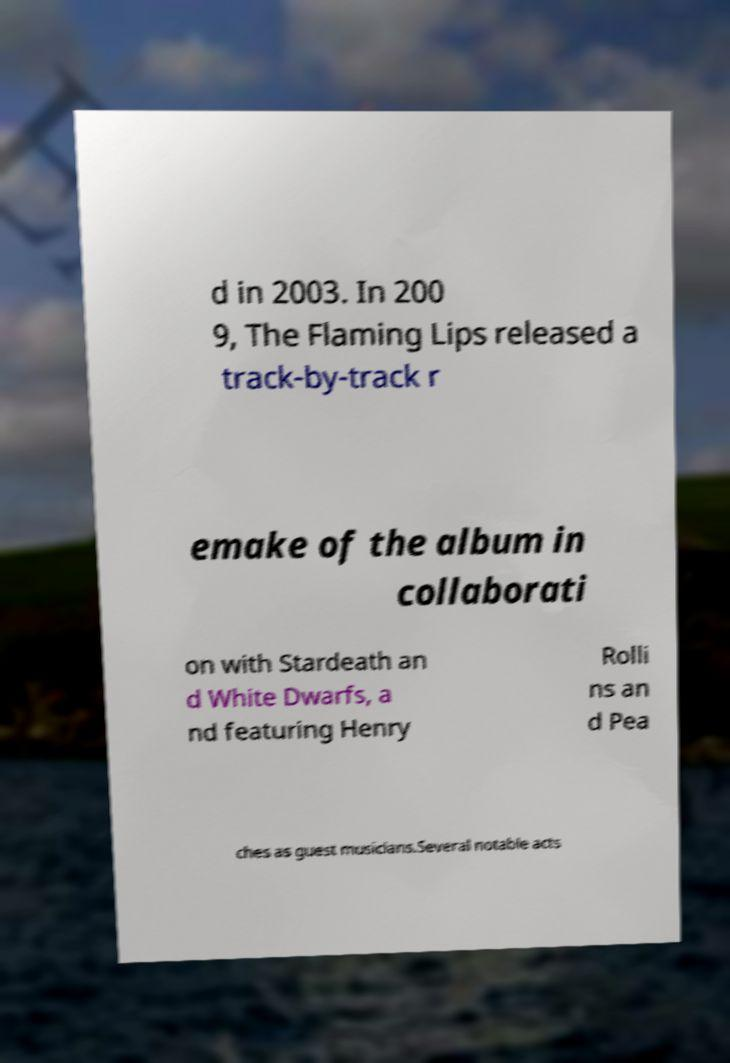Could you extract and type out the text from this image? d in 2003. In 200 9, The Flaming Lips released a track-by-track r emake of the album in collaborati on with Stardeath an d White Dwarfs, a nd featuring Henry Rolli ns an d Pea ches as guest musicians.Several notable acts 